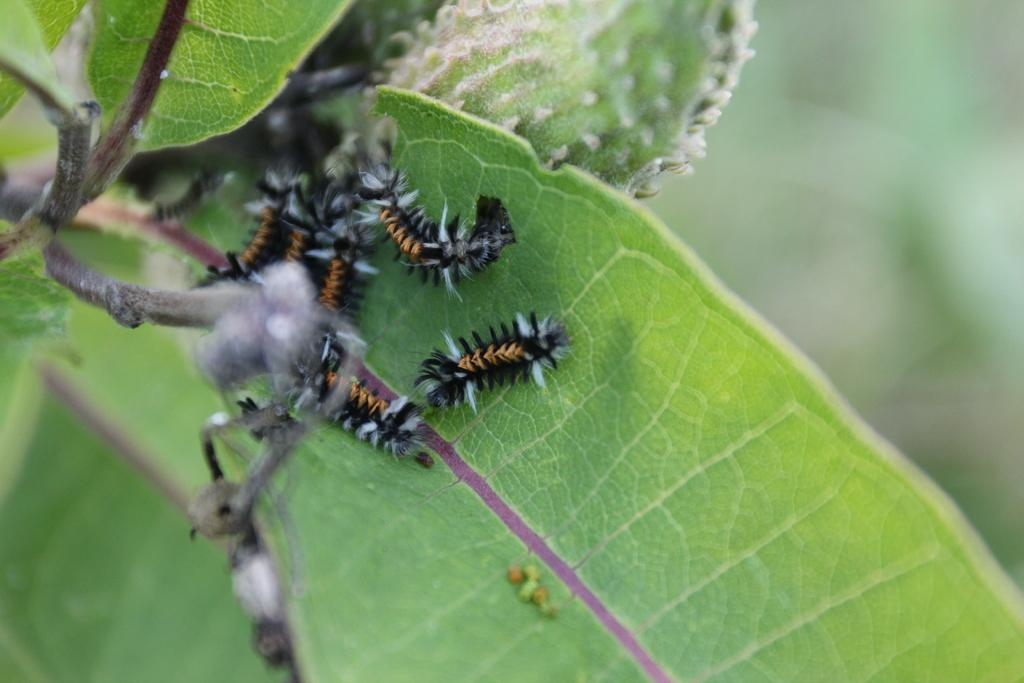What is the main subject of the image? The main subject of the image is insects on a leaf. Can you describe the background of the image? The background of the image is blurred. What type of iron can be seen in the image? There is no iron present in the image; it features insects on a leaf with a blurred background. Where is the volleyball court located in the image? There is no volleyball court present in the image. 